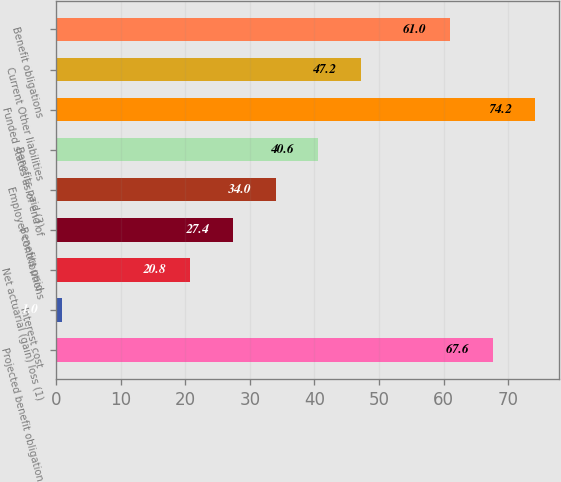Convert chart. <chart><loc_0><loc_0><loc_500><loc_500><bar_chart><fcel>Projected benefit obligation<fcel>Interest cost<fcel>Net actuarial (gain) loss (1)<fcel>Benefits paid<fcel>Employer contributions<fcel>Benefits paid (3)<fcel>Funded status as of end of<fcel>Current Other liabilities<fcel>Benefit obligations<nl><fcel>67.6<fcel>1<fcel>20.8<fcel>27.4<fcel>34<fcel>40.6<fcel>74.2<fcel>47.2<fcel>61<nl></chart> 